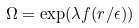<formula> <loc_0><loc_0><loc_500><loc_500>\Omega = \exp ( \lambda f ( r / \epsilon ) )</formula> 